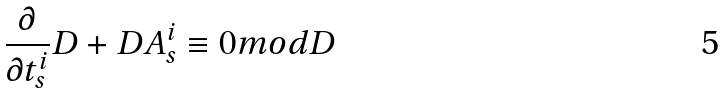<formula> <loc_0><loc_0><loc_500><loc_500>\frac { \partial } { \partial t _ { s } ^ { i } } D + D A _ { s } ^ { i } \equiv 0 m o d D</formula> 